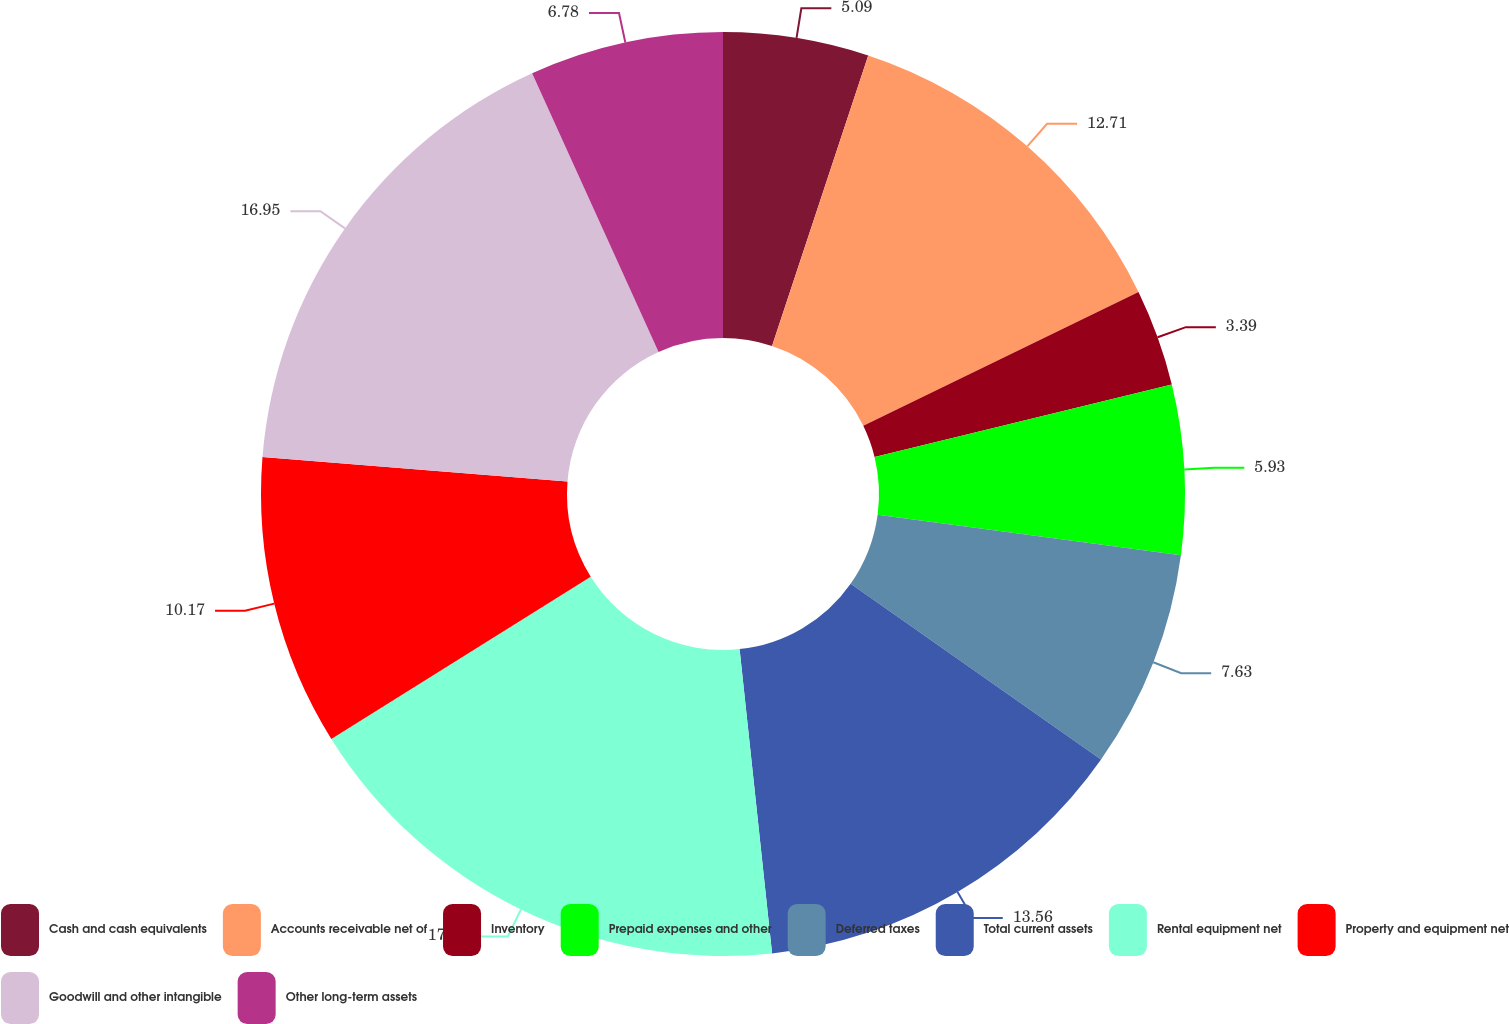<chart> <loc_0><loc_0><loc_500><loc_500><pie_chart><fcel>Cash and cash equivalents<fcel>Accounts receivable net of<fcel>Inventory<fcel>Prepaid expenses and other<fcel>Deferred taxes<fcel>Total current assets<fcel>Rental equipment net<fcel>Property and equipment net<fcel>Goodwill and other intangible<fcel>Other long-term assets<nl><fcel>5.09%<fcel>12.71%<fcel>3.39%<fcel>5.93%<fcel>7.63%<fcel>13.56%<fcel>17.8%<fcel>10.17%<fcel>16.95%<fcel>6.78%<nl></chart> 